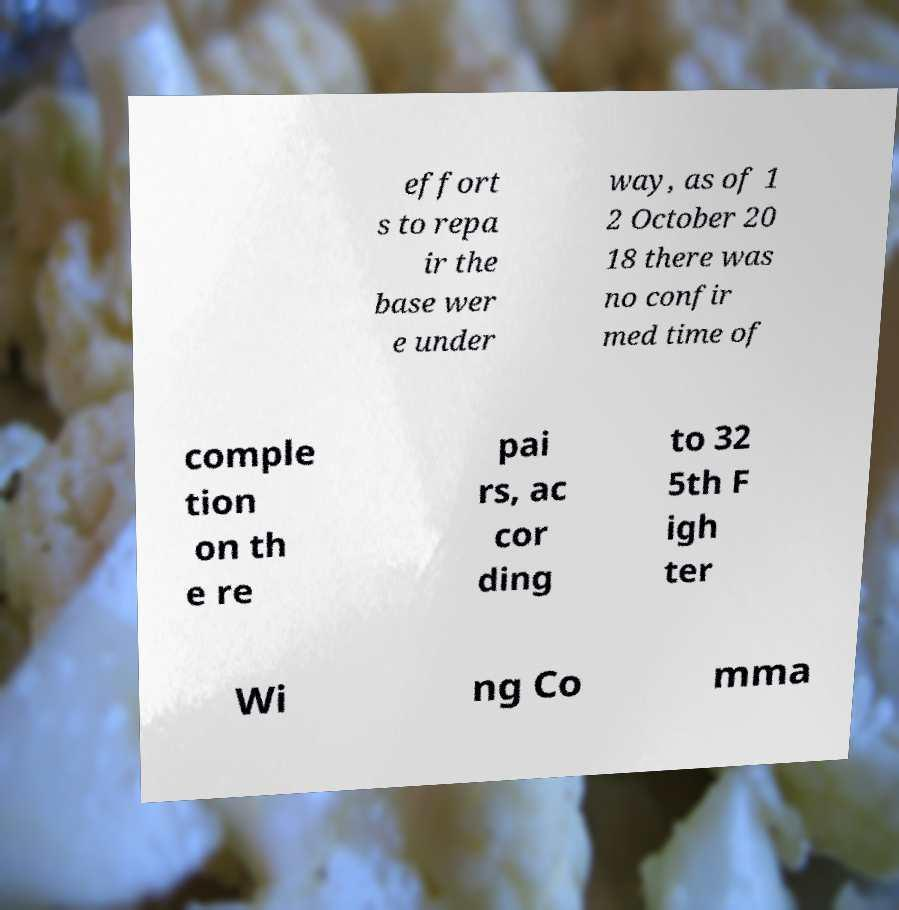What messages or text are displayed in this image? I need them in a readable, typed format. effort s to repa ir the base wer e under way, as of 1 2 October 20 18 there was no confir med time of comple tion on th e re pai rs, ac cor ding to 32 5th F igh ter Wi ng Co mma 